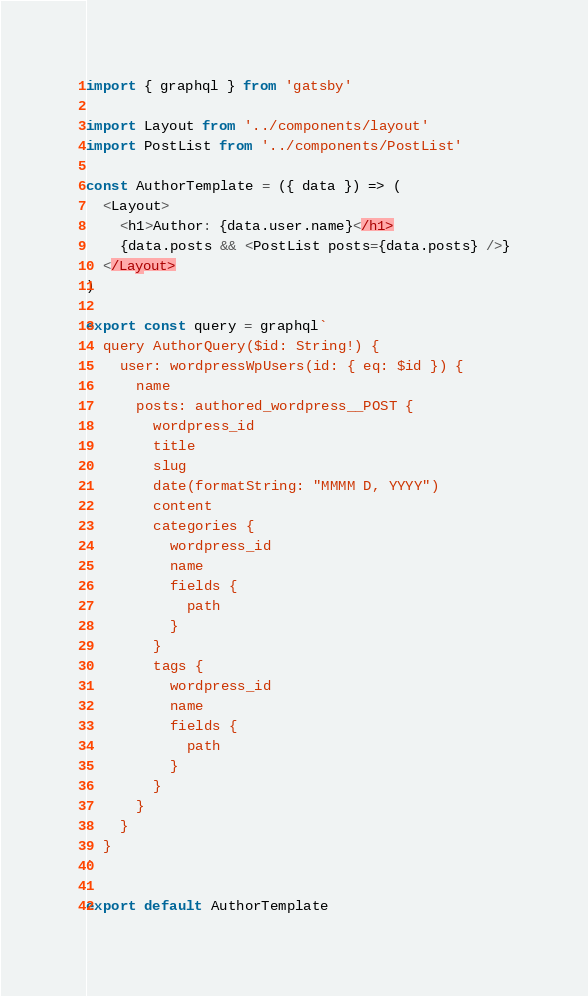Convert code to text. <code><loc_0><loc_0><loc_500><loc_500><_JavaScript_>import { graphql } from 'gatsby'

import Layout from '../components/layout'
import PostList from '../components/PostList'

const AuthorTemplate = ({ data }) => (
  <Layout>
    <h1>Author: {data.user.name}</h1>
    {data.posts && <PostList posts={data.posts} />}
  </Layout>
)

export const query = graphql`
  query AuthorQuery($id: String!) {
    user: wordpressWpUsers(id: { eq: $id }) {
      name
      posts: authored_wordpress__POST {
        wordpress_id
        title
        slug
        date(formatString: "MMMM D, YYYY")
        content
        categories {
          wordpress_id
          name
          fields {
            path
          }
        }
        tags {
          wordpress_id
          name
          fields {
            path
          }
        }
      }
    }
  }
`

export default AuthorTemplate
</code> 